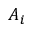Convert formula to latex. <formula><loc_0><loc_0><loc_500><loc_500>A _ { i }</formula> 